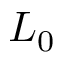Convert formula to latex. <formula><loc_0><loc_0><loc_500><loc_500>L _ { 0 }</formula> 